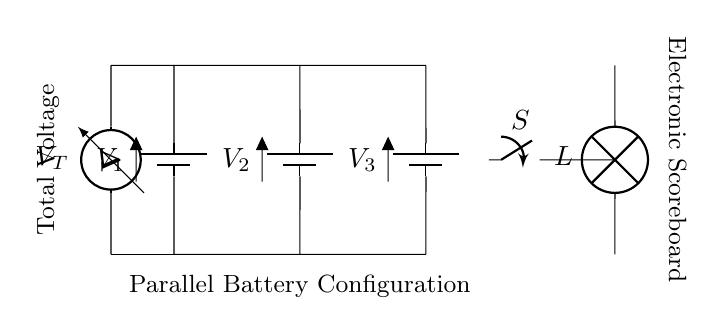What components are present in the circuit? The circuit includes three batteries, a switch, a lamp, and a voltmeter. These components can be visually identified in the circuit diagram.
Answer: three batteries, a switch, a lamp, and a voltmeter What is the configuration type of the batteries? The batteries are arranged in a parallel configuration, which can be understood by observing that their positive terminals are connected together, and their negative terminals are connected together.
Answer: parallel What is the total voltage across the circuit? The total voltage in a parallel configuration is determined by the voltage of a single battery, which should be visible in the circuit. Given that the schematic only shows one voltage label across a battery, this indicates the voltage is that of one battery.
Answer: V1 (voltage of a single battery) How many batteries contribute to the circuit? There are three batteries connected in parallel, as indicated by their arrangement and connections in the diagram. Each battery is wired in such a way that they can independently supply current while maintaining the same voltage level across the overall circuit.
Answer: three What does the switch do in this circuit? The switch connects or disconnects the lamp from the power source. If the switch is closed, the lamp will light up; if open, the current flow is interrupted and the lamp remains off. This functionality is essential for controlling the operation of the electronic scoreboard.
Answer: controls the lamp What effect does disconnecting one battery have on the circuit? Disconnecting one battery in a parallel configuration does not affect the voltage supplied to the circuit, as the remaining batteries continue to provide the same voltage. However, it reduces the total available current from the battery bank.
Answer: no voltage change, reduced current Why is a voltmeter included in the circuit? The voltmeter is included to measure the total voltage across the circuit. This is important for ensuring that the batteries are functioning correctly and providing adequate power to the electronic scoreboard.
Answer: measures total voltage 